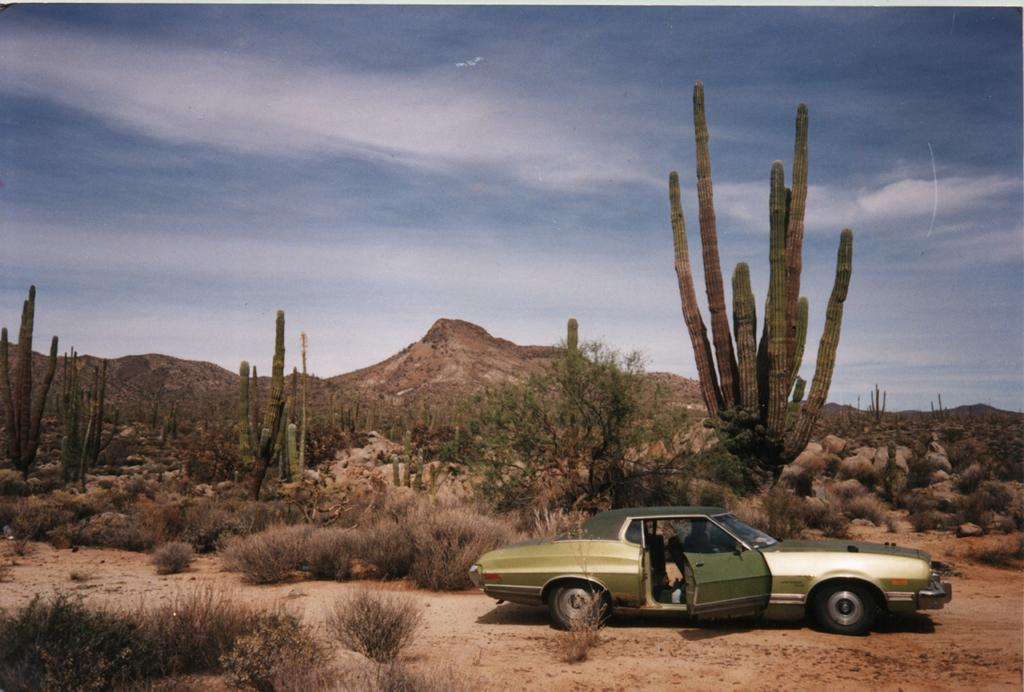What is located on the ground in the image? There is a vehicle on the ground in the image. What type of natural environment can be seen in the background of the image? There is grass, trees, and hills visible in the background of the image. What is visible in the sky in the image? Clouds are present in the sky in the image. What is the weight of the needle in the image? There is no needle present in the image, so it is not possible to determine its weight. 